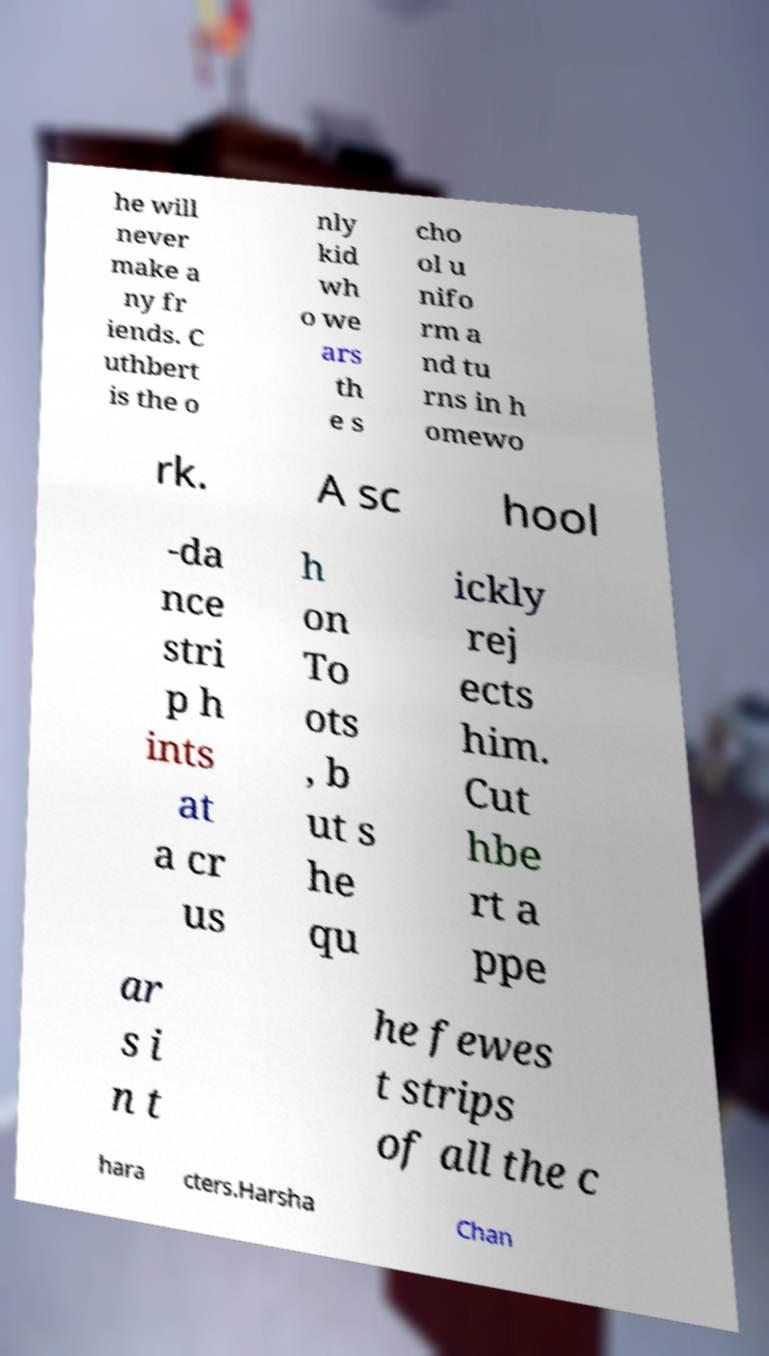There's text embedded in this image that I need extracted. Can you transcribe it verbatim? he will never make a ny fr iends. C uthbert is the o nly kid wh o we ars th e s cho ol u nifo rm a nd tu rns in h omewo rk. A sc hool -da nce stri p h ints at a cr us h on To ots , b ut s he qu ickly rej ects him. Cut hbe rt a ppe ar s i n t he fewes t strips of all the c hara cters.Harsha Chan 